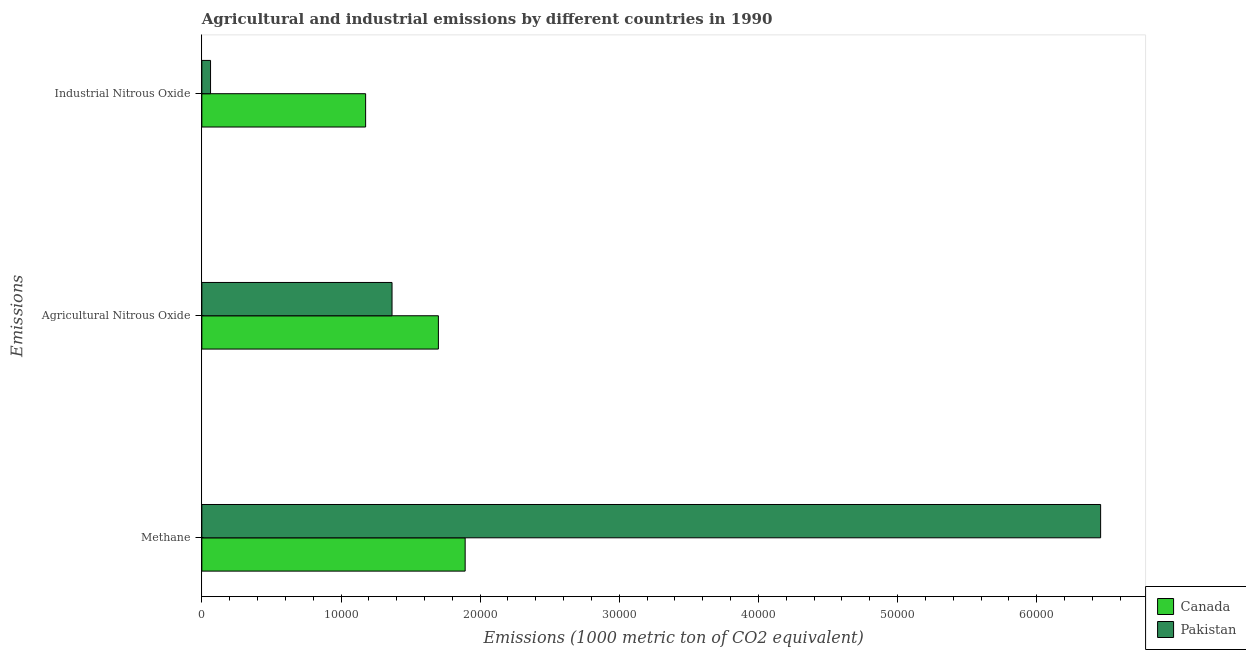How many different coloured bars are there?
Provide a succinct answer. 2. How many groups of bars are there?
Offer a very short reply. 3. Are the number of bars per tick equal to the number of legend labels?
Make the answer very short. Yes. Are the number of bars on each tick of the Y-axis equal?
Your response must be concise. Yes. What is the label of the 3rd group of bars from the top?
Ensure brevity in your answer.  Methane. What is the amount of industrial nitrous oxide emissions in Canada?
Make the answer very short. 1.18e+04. Across all countries, what is the maximum amount of industrial nitrous oxide emissions?
Provide a succinct answer. 1.18e+04. Across all countries, what is the minimum amount of methane emissions?
Your answer should be very brief. 1.89e+04. In which country was the amount of methane emissions maximum?
Your answer should be very brief. Pakistan. In which country was the amount of methane emissions minimum?
Make the answer very short. Canada. What is the total amount of industrial nitrous oxide emissions in the graph?
Ensure brevity in your answer.  1.24e+04. What is the difference between the amount of agricultural nitrous oxide emissions in Canada and that in Pakistan?
Your answer should be very brief. 3331.2. What is the difference between the amount of methane emissions in Pakistan and the amount of industrial nitrous oxide emissions in Canada?
Make the answer very short. 5.28e+04. What is the average amount of agricultural nitrous oxide emissions per country?
Keep it short and to the point. 1.53e+04. What is the difference between the amount of industrial nitrous oxide emissions and amount of methane emissions in Pakistan?
Your answer should be very brief. -6.40e+04. In how many countries, is the amount of industrial nitrous oxide emissions greater than 22000 metric ton?
Your answer should be compact. 0. What is the ratio of the amount of industrial nitrous oxide emissions in Pakistan to that in Canada?
Provide a short and direct response. 0.05. Is the amount of methane emissions in Pakistan less than that in Canada?
Offer a terse response. No. What is the difference between the highest and the second highest amount of methane emissions?
Ensure brevity in your answer.  4.57e+04. What is the difference between the highest and the lowest amount of methane emissions?
Provide a succinct answer. 4.57e+04. In how many countries, is the amount of methane emissions greater than the average amount of methane emissions taken over all countries?
Offer a very short reply. 1. What does the 2nd bar from the top in Methane represents?
Your answer should be compact. Canada. Are all the bars in the graph horizontal?
Your answer should be compact. Yes. How many countries are there in the graph?
Keep it short and to the point. 2. Does the graph contain grids?
Give a very brief answer. No. Where does the legend appear in the graph?
Your answer should be compact. Bottom right. How are the legend labels stacked?
Keep it short and to the point. Vertical. What is the title of the graph?
Your response must be concise. Agricultural and industrial emissions by different countries in 1990. Does "Korea (Republic)" appear as one of the legend labels in the graph?
Keep it short and to the point. No. What is the label or title of the X-axis?
Ensure brevity in your answer.  Emissions (1000 metric ton of CO2 equivalent). What is the label or title of the Y-axis?
Your response must be concise. Emissions. What is the Emissions (1000 metric ton of CO2 equivalent) in Canada in Methane?
Your response must be concise. 1.89e+04. What is the Emissions (1000 metric ton of CO2 equivalent) in Pakistan in Methane?
Give a very brief answer. 6.46e+04. What is the Emissions (1000 metric ton of CO2 equivalent) of Canada in Agricultural Nitrous Oxide?
Provide a succinct answer. 1.70e+04. What is the Emissions (1000 metric ton of CO2 equivalent) in Pakistan in Agricultural Nitrous Oxide?
Ensure brevity in your answer.  1.37e+04. What is the Emissions (1000 metric ton of CO2 equivalent) of Canada in Industrial Nitrous Oxide?
Provide a succinct answer. 1.18e+04. What is the Emissions (1000 metric ton of CO2 equivalent) of Pakistan in Industrial Nitrous Oxide?
Provide a short and direct response. 625. Across all Emissions, what is the maximum Emissions (1000 metric ton of CO2 equivalent) in Canada?
Your answer should be very brief. 1.89e+04. Across all Emissions, what is the maximum Emissions (1000 metric ton of CO2 equivalent) in Pakistan?
Provide a succinct answer. 6.46e+04. Across all Emissions, what is the minimum Emissions (1000 metric ton of CO2 equivalent) of Canada?
Your response must be concise. 1.18e+04. Across all Emissions, what is the minimum Emissions (1000 metric ton of CO2 equivalent) in Pakistan?
Provide a short and direct response. 625. What is the total Emissions (1000 metric ton of CO2 equivalent) in Canada in the graph?
Keep it short and to the point. 4.77e+04. What is the total Emissions (1000 metric ton of CO2 equivalent) in Pakistan in the graph?
Provide a succinct answer. 7.89e+04. What is the difference between the Emissions (1000 metric ton of CO2 equivalent) in Canada in Methane and that in Agricultural Nitrous Oxide?
Your answer should be compact. 1924.1. What is the difference between the Emissions (1000 metric ton of CO2 equivalent) in Pakistan in Methane and that in Agricultural Nitrous Oxide?
Provide a succinct answer. 5.09e+04. What is the difference between the Emissions (1000 metric ton of CO2 equivalent) in Canada in Methane and that in Industrial Nitrous Oxide?
Offer a terse response. 7153.5. What is the difference between the Emissions (1000 metric ton of CO2 equivalent) in Pakistan in Methane and that in Industrial Nitrous Oxide?
Offer a terse response. 6.40e+04. What is the difference between the Emissions (1000 metric ton of CO2 equivalent) of Canada in Agricultural Nitrous Oxide and that in Industrial Nitrous Oxide?
Provide a succinct answer. 5229.4. What is the difference between the Emissions (1000 metric ton of CO2 equivalent) in Pakistan in Agricultural Nitrous Oxide and that in Industrial Nitrous Oxide?
Provide a short and direct response. 1.30e+04. What is the difference between the Emissions (1000 metric ton of CO2 equivalent) of Canada in Methane and the Emissions (1000 metric ton of CO2 equivalent) of Pakistan in Agricultural Nitrous Oxide?
Give a very brief answer. 5255.3. What is the difference between the Emissions (1000 metric ton of CO2 equivalent) of Canada in Methane and the Emissions (1000 metric ton of CO2 equivalent) of Pakistan in Industrial Nitrous Oxide?
Offer a very short reply. 1.83e+04. What is the difference between the Emissions (1000 metric ton of CO2 equivalent) of Canada in Agricultural Nitrous Oxide and the Emissions (1000 metric ton of CO2 equivalent) of Pakistan in Industrial Nitrous Oxide?
Your response must be concise. 1.64e+04. What is the average Emissions (1000 metric ton of CO2 equivalent) of Canada per Emissions?
Ensure brevity in your answer.  1.59e+04. What is the average Emissions (1000 metric ton of CO2 equivalent) of Pakistan per Emissions?
Keep it short and to the point. 2.63e+04. What is the difference between the Emissions (1000 metric ton of CO2 equivalent) in Canada and Emissions (1000 metric ton of CO2 equivalent) in Pakistan in Methane?
Your answer should be compact. -4.57e+04. What is the difference between the Emissions (1000 metric ton of CO2 equivalent) in Canada and Emissions (1000 metric ton of CO2 equivalent) in Pakistan in Agricultural Nitrous Oxide?
Provide a succinct answer. 3331.2. What is the difference between the Emissions (1000 metric ton of CO2 equivalent) of Canada and Emissions (1000 metric ton of CO2 equivalent) of Pakistan in Industrial Nitrous Oxide?
Make the answer very short. 1.11e+04. What is the ratio of the Emissions (1000 metric ton of CO2 equivalent) of Canada in Methane to that in Agricultural Nitrous Oxide?
Ensure brevity in your answer.  1.11. What is the ratio of the Emissions (1000 metric ton of CO2 equivalent) in Pakistan in Methane to that in Agricultural Nitrous Oxide?
Your answer should be very brief. 4.73. What is the ratio of the Emissions (1000 metric ton of CO2 equivalent) of Canada in Methane to that in Industrial Nitrous Oxide?
Make the answer very short. 1.61. What is the ratio of the Emissions (1000 metric ton of CO2 equivalent) of Pakistan in Methane to that in Industrial Nitrous Oxide?
Offer a very short reply. 103.35. What is the ratio of the Emissions (1000 metric ton of CO2 equivalent) of Canada in Agricultural Nitrous Oxide to that in Industrial Nitrous Oxide?
Make the answer very short. 1.44. What is the ratio of the Emissions (1000 metric ton of CO2 equivalent) of Pakistan in Agricultural Nitrous Oxide to that in Industrial Nitrous Oxide?
Keep it short and to the point. 21.87. What is the difference between the highest and the second highest Emissions (1000 metric ton of CO2 equivalent) of Canada?
Your answer should be very brief. 1924.1. What is the difference between the highest and the second highest Emissions (1000 metric ton of CO2 equivalent) in Pakistan?
Make the answer very short. 5.09e+04. What is the difference between the highest and the lowest Emissions (1000 metric ton of CO2 equivalent) of Canada?
Make the answer very short. 7153.5. What is the difference between the highest and the lowest Emissions (1000 metric ton of CO2 equivalent) of Pakistan?
Give a very brief answer. 6.40e+04. 